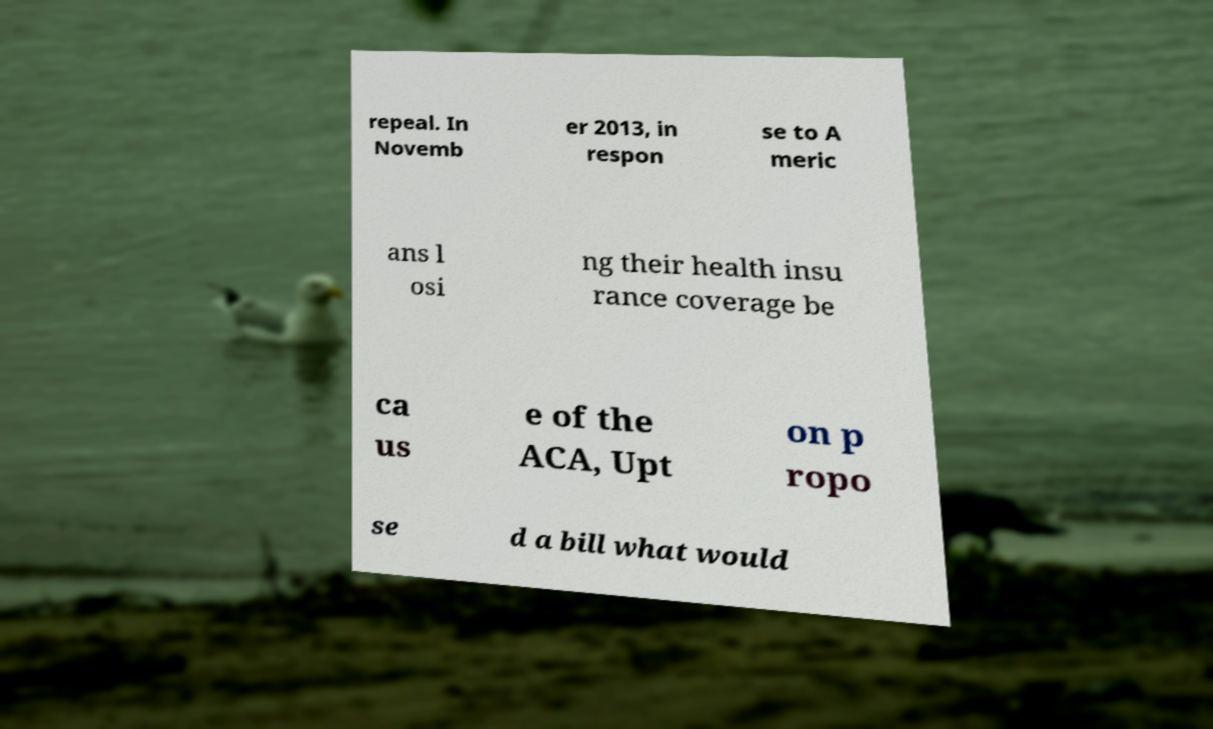Please identify and transcribe the text found in this image. repeal. In Novemb er 2013, in respon se to A meric ans l osi ng their health insu rance coverage be ca us e of the ACA, Upt on p ropo se d a bill what would 